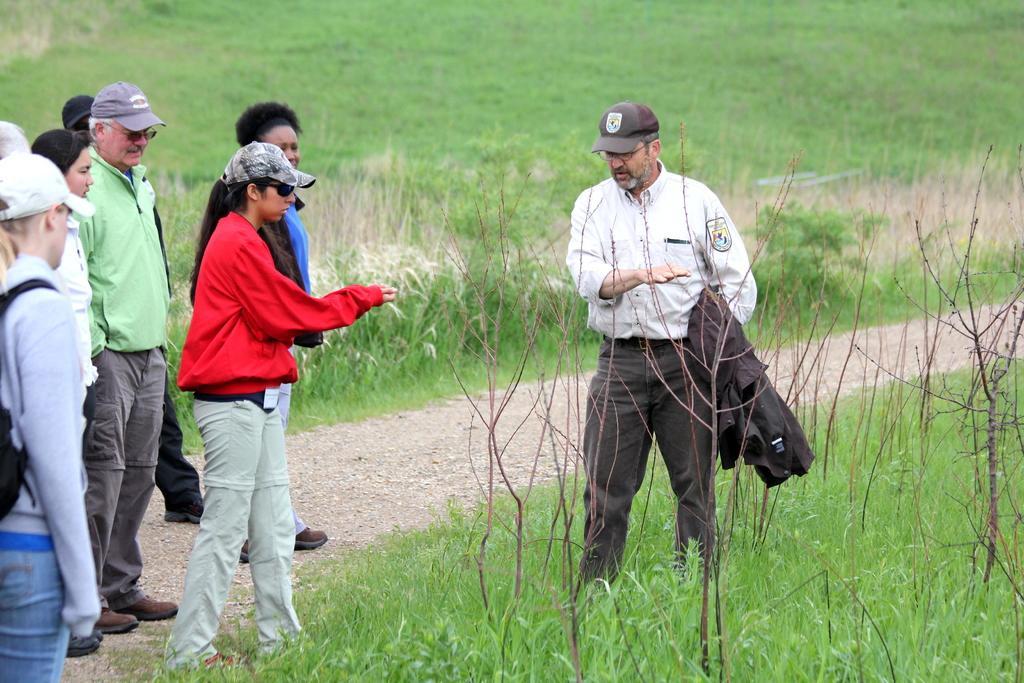Please provide a concise description of this image. In this image there is a man standing, he is holding an object, he is wearing a cap, there are group of persons standing towards the left of the image, there is grass towards the top of the image, there is grass towards the bottom of the image, there are plants towards the bottom of the image, there are two women wearing caps, there is a woman wearing a bag towards the left of the image. 